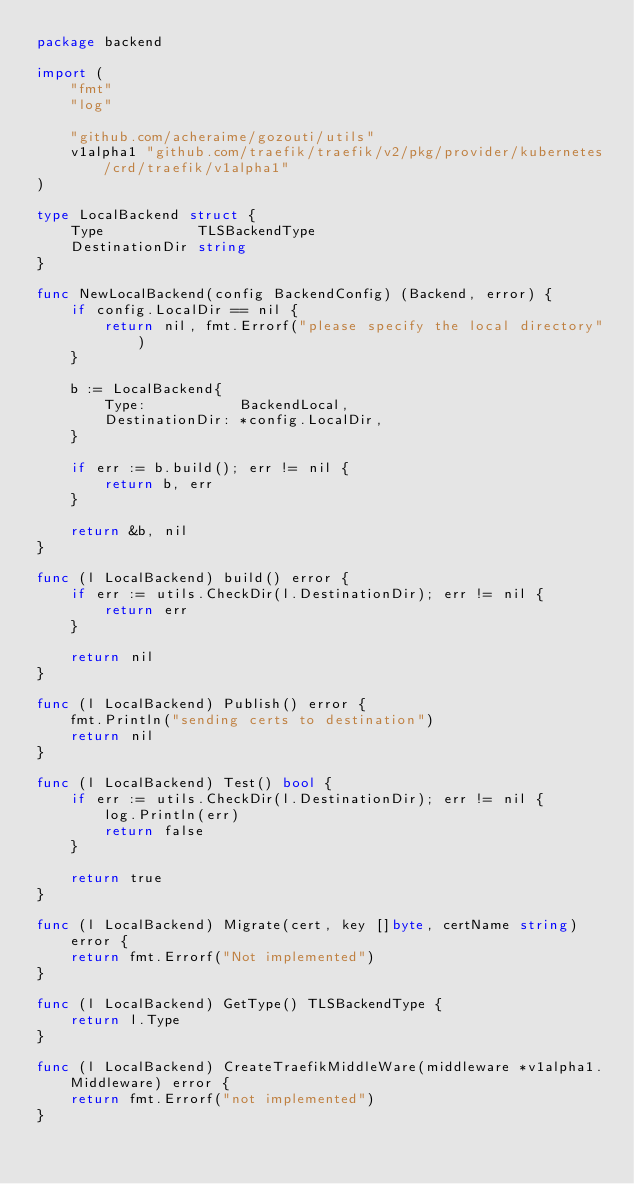<code> <loc_0><loc_0><loc_500><loc_500><_Go_>package backend

import (
	"fmt"
	"log"

	"github.com/acheraime/gozouti/utils"
	v1alpha1 "github.com/traefik/traefik/v2/pkg/provider/kubernetes/crd/traefik/v1alpha1"
)

type LocalBackend struct {
	Type           TLSBackendType
	DestinationDir string
}

func NewLocalBackend(config BackendConfig) (Backend, error) {
	if config.LocalDir == nil {
		return nil, fmt.Errorf("please specify the local directory")
	}

	b := LocalBackend{
		Type:           BackendLocal,
		DestinationDir: *config.LocalDir,
	}

	if err := b.build(); err != nil {
		return b, err
	}

	return &b, nil
}

func (l LocalBackend) build() error {
	if err := utils.CheckDir(l.DestinationDir); err != nil {
		return err
	}

	return nil
}

func (l LocalBackend) Publish() error {
	fmt.Println("sending certs to destination")
	return nil
}

func (l LocalBackend) Test() bool {
	if err := utils.CheckDir(l.DestinationDir); err != nil {
		log.Println(err)
		return false
	}

	return true
}

func (l LocalBackend) Migrate(cert, key []byte, certName string) error {
	return fmt.Errorf("Not implemented")
}

func (l LocalBackend) GetType() TLSBackendType {
	return l.Type
}

func (l LocalBackend) CreateTraefikMiddleWare(middleware *v1alpha1.Middleware) error {
	return fmt.Errorf("not implemented")
}
</code> 